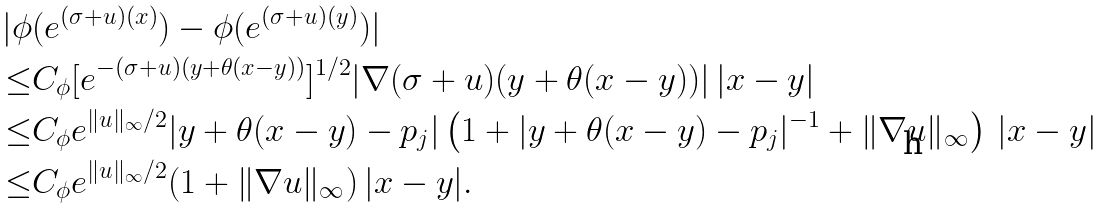Convert formula to latex. <formula><loc_0><loc_0><loc_500><loc_500>| \phi & ( e ^ { ( \sigma + u ) ( x ) } ) - \phi ( e ^ { ( \sigma + u ) ( y ) } ) | \\ \leq & C _ { \phi } [ e ^ { - ( \sigma + u ) ( y + \theta ( x - y ) ) } ] ^ { 1 / 2 } | \nabla ( \sigma + u ) ( y + \theta ( x - y ) ) | \, | x - y | \\ \leq & C _ { \phi } e ^ { \| u \| _ { \infty } / 2 } | y + \theta ( x - y ) - p _ { j } | \left ( 1 + | y + \theta ( x - y ) - p _ { j } | ^ { - 1 } + \| \nabla u \| _ { \infty } \right ) \, | x - y | \\ \leq & C _ { \phi } e ^ { \| u \| _ { \infty } / 2 } ( 1 + \| \nabla u \| _ { \infty } ) \, | x - y | .</formula> 